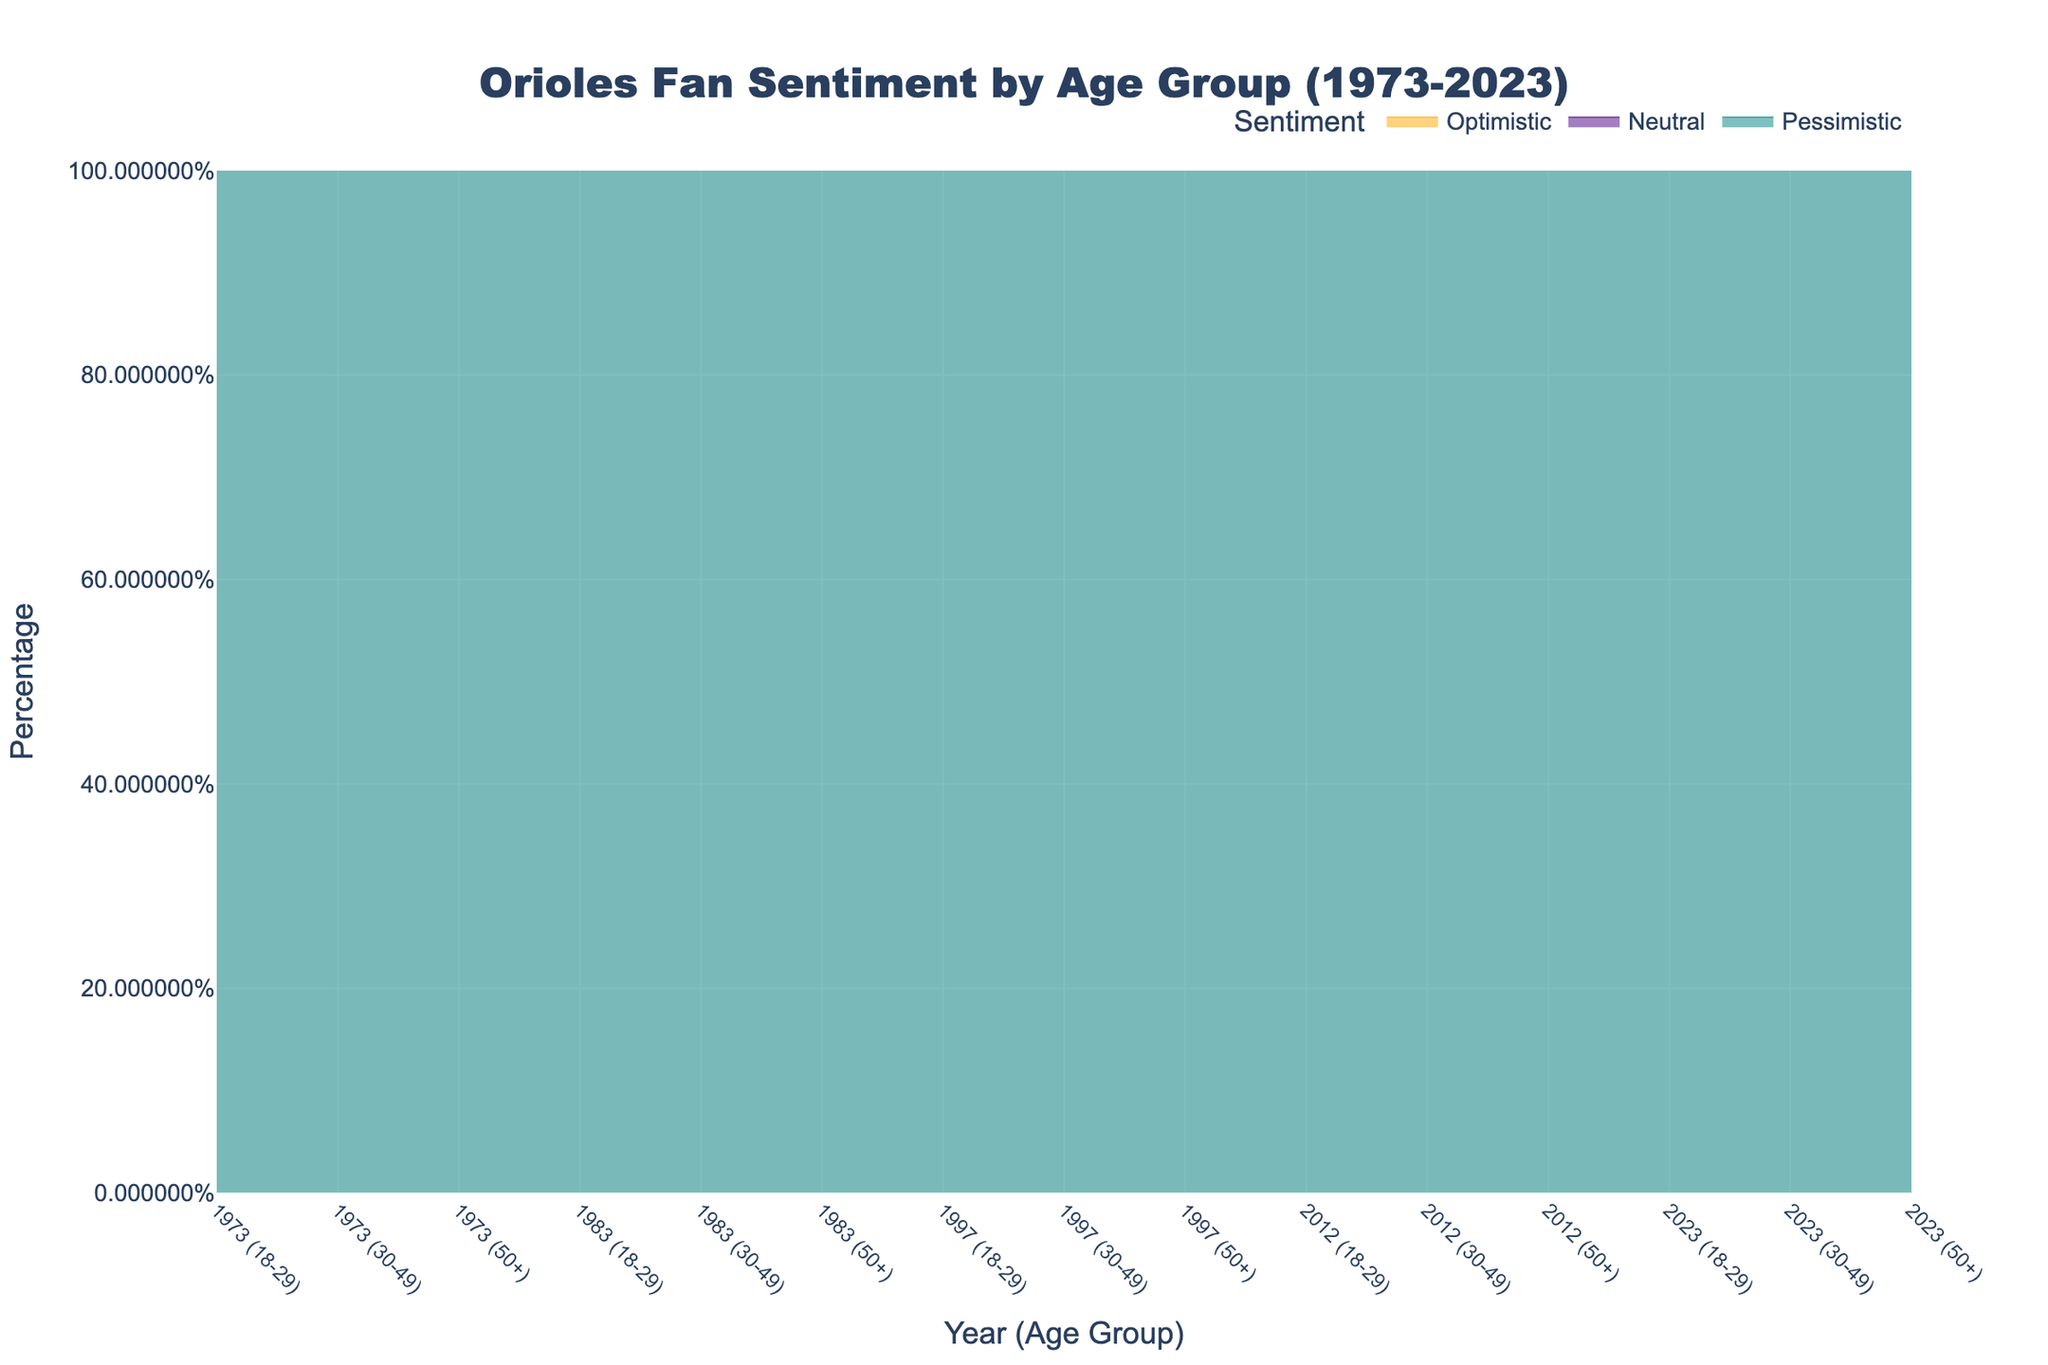When did the 18-29 age group have the highest percentage of optimistic sentiment? To identify when the 18-29 age group had the highest percentage of optimistic sentiment, look at the line for optimistic sentiment (orange) segmented by the 18-29 age group across the time span. The peak percentage was in 1983.
Answer: 1983 How does the percentage of pessimistic sentiment in the 30-49 age group compare between 1973 and 2023? Compare the height of the teal area representing pessimistic sentiment for the 30-49 age group in 1973 and 2023. For 1973, the percentage is 25%, and for 2023, it is the same at 25%.
Answer: Equal What trend do you observe in the neutral sentiment of the 50+ age group over the years? Observe the purple area representing neutral sentiment for the 50+ age group over time. Notice that it starts at 30%, decreases to 25% by 1983, then increases to around 35% by 1997 and remains stable around 30-35% till 2023.
Answer: Decline then stable Which age group had the highest overall percentage of optimistic sentiment in 1983? Examine the orange areas for each age group in 1983. The 50+ age group had the highest percentage of optimistic sentiment at 60%.
Answer: 50+ During which year was the sentiment in the 18-29 age group the most evenly distributed across optimistic, neutral, and pessimistic? Look for the year where the areas for optimistic, neutral, and pessimistic sentiments (orange, purple, teal) in the 18-29 age group are most similar in size. In 1997, the distribution is 30% optimistic, 40% neutral, and 30% pessimistic.
Answer: 1997 How does the optimistic sentiment in the 30-49 age group in 2012 compare to that in 2023? Compare the height of the orange area representing optimistic sentiment in the 30-49 age group between 2012 and 2023. In 2012, it's 50%, whereas in 2023, it's 40%.
Answer: Decreased by 10% Which age group showed the least variation in pessimistic sentiment from 1973 to 2023? Assess the teal areas for each age group over the entire timeline. The 50+ age group consistently ranges from 15% to 25% showing the least variation.
Answer: 50+ What was the most common sentiment in the 50+ age group in 2023? Look at the largest area section representing one of the three sentiments (orange, purple, teal) within the 50+ age group in 2023. Optimistic sentiment (orange) is the largest at 45%.
Answer: Optimistic In which year was the percentage of pessimistic sentiment highest across all age groups collectively? Identify the year where the combined height of the teal area (representing pessimistic sentiment) across all age groups is the highest. In 1997, the pessimistic sentiment was highest overall.
Answer: 1997 